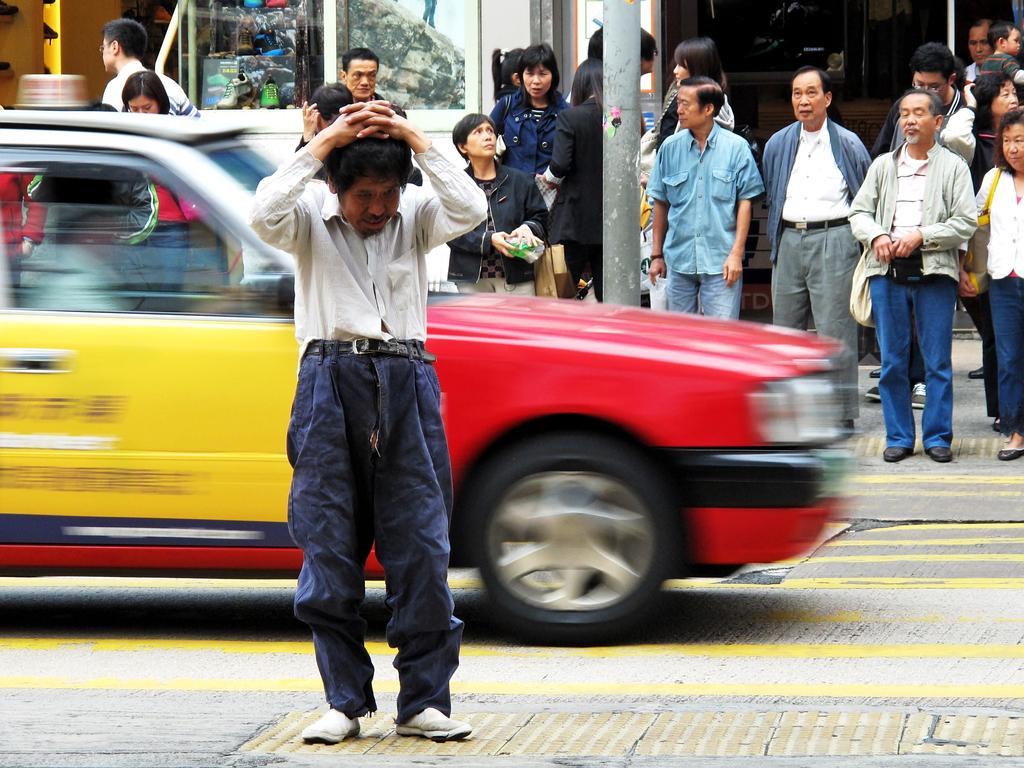Describe this image in one or two sentences. In this image there is a man standing, there are group of persons standing towards the right of the image, the persons are wearing a bag, the persons are holding an object, there is a wall towards the left of the image, there is a pole towards the top of the image, there is road towards the bottom of the image, there is a car towards the left of the image, there is a person driving a car. 